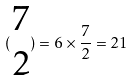<formula> <loc_0><loc_0><loc_500><loc_500>( \begin{matrix} 7 \\ 2 \end{matrix} ) = 6 \times \frac { 7 } { 2 } = 2 1</formula> 